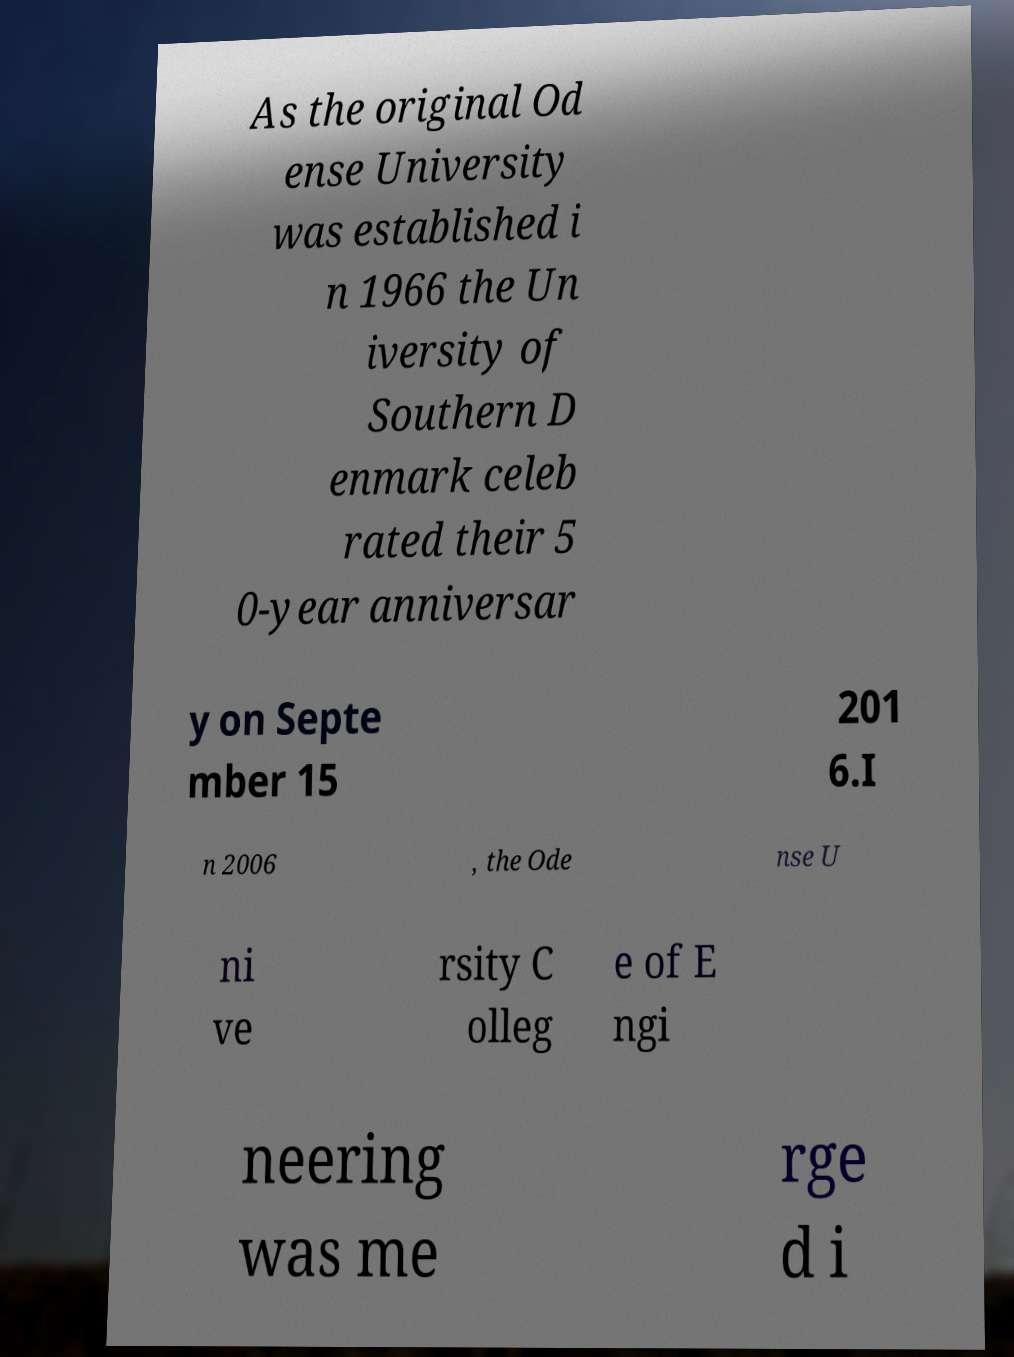There's text embedded in this image that I need extracted. Can you transcribe it verbatim? As the original Od ense University was established i n 1966 the Un iversity of Southern D enmark celeb rated their 5 0-year anniversar y on Septe mber 15 201 6.I n 2006 , the Ode nse U ni ve rsity C olleg e of E ngi neering was me rge d i 